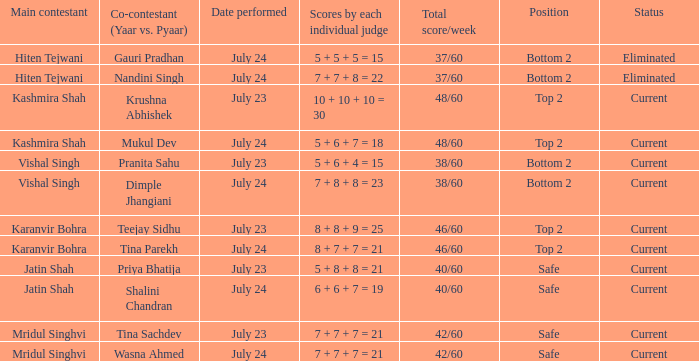Who is the main contestant with a total score/week of 42/60 and a co-contestant (Yaar vs. Pyaa) of Tina Sachdev? Mridul Singhvi. 